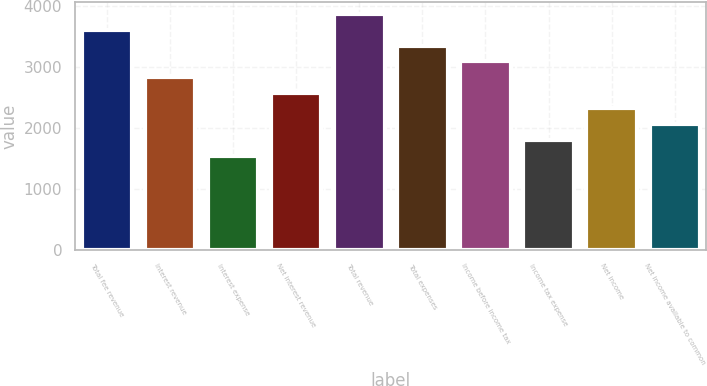<chart> <loc_0><loc_0><loc_500><loc_500><bar_chart><fcel>Total fee revenue<fcel>Interest revenue<fcel>Interest expense<fcel>Net interest revenue<fcel>Total revenue<fcel>Total expenses<fcel>Income before income tax<fcel>Income tax expense<fcel>Net income<fcel>Net income available to common<nl><fcel>3614.68<fcel>2840.17<fcel>1549.32<fcel>2582<fcel>3872.85<fcel>3356.51<fcel>3098.34<fcel>1807.49<fcel>2323.83<fcel>2065.66<nl></chart> 